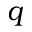<formula> <loc_0><loc_0><loc_500><loc_500>q</formula> 